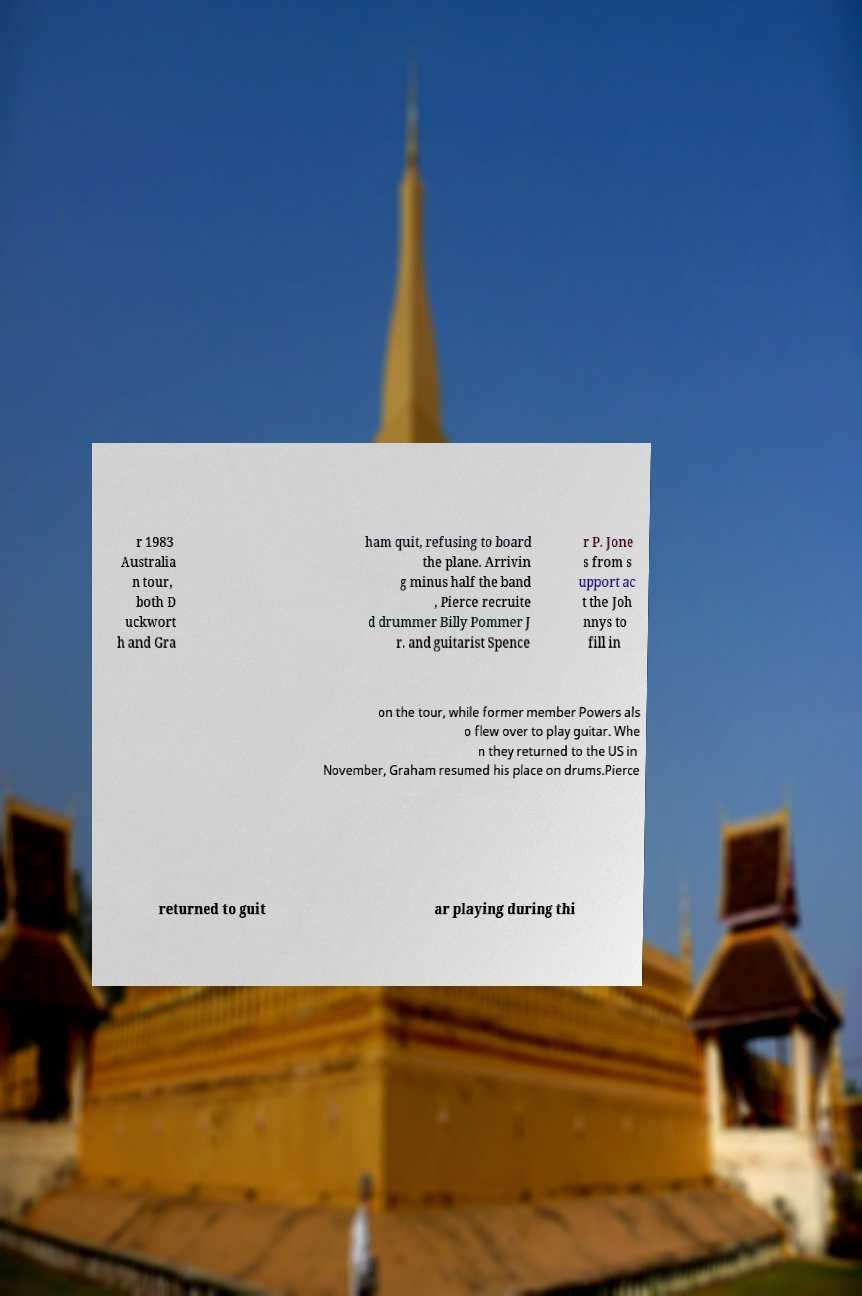What messages or text are displayed in this image? I need them in a readable, typed format. r 1983 Australia n tour, both D uckwort h and Gra ham quit, refusing to board the plane. Arrivin g minus half the band , Pierce recruite d drummer Billy Pommer J r. and guitarist Spence r P. Jone s from s upport ac t the Joh nnys to fill in on the tour, while former member Powers als o flew over to play guitar. Whe n they returned to the US in November, Graham resumed his place on drums.Pierce returned to guit ar playing during thi 